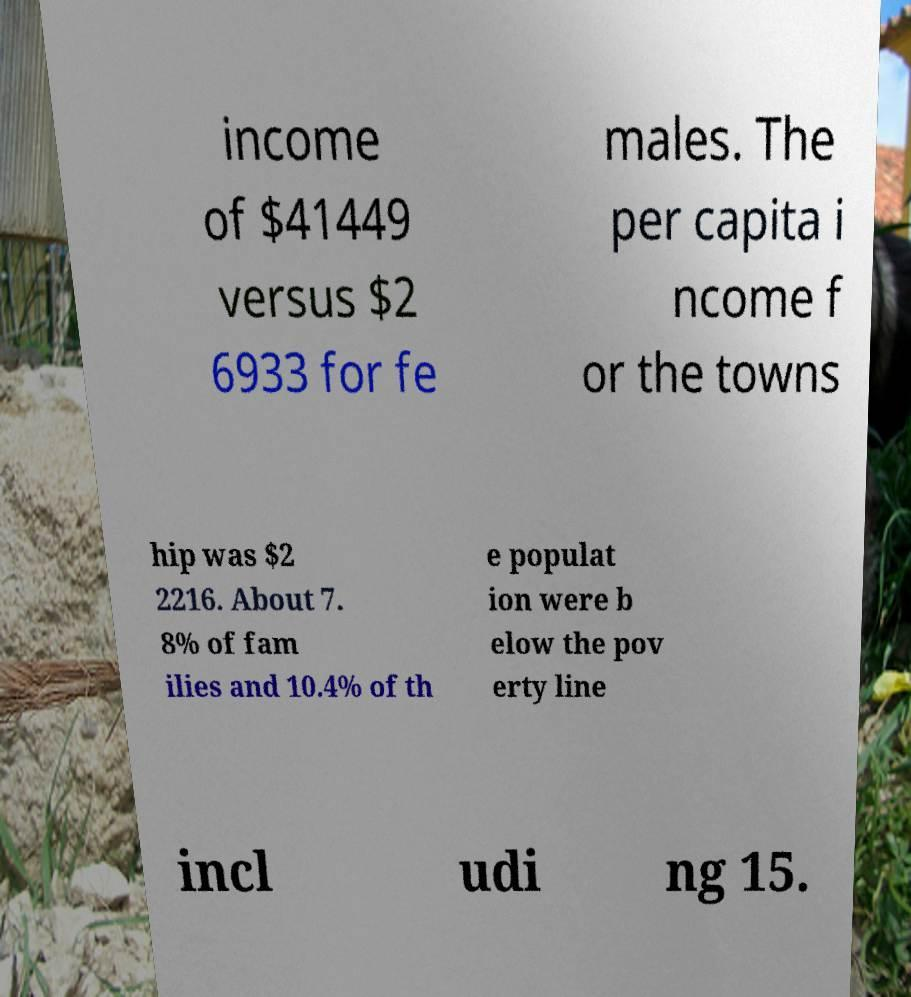Could you assist in decoding the text presented in this image and type it out clearly? income of $41449 versus $2 6933 for fe males. The per capita i ncome f or the towns hip was $2 2216. About 7. 8% of fam ilies and 10.4% of th e populat ion were b elow the pov erty line incl udi ng 15. 